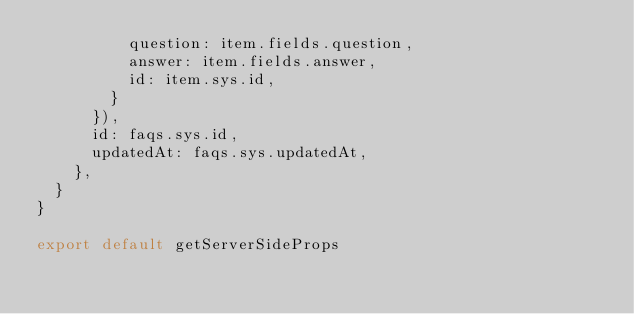<code> <loc_0><loc_0><loc_500><loc_500><_TypeScript_>          question: item.fields.question,
          answer: item.fields.answer,
          id: item.sys.id,
        }
      }),
      id: faqs.sys.id,
      updatedAt: faqs.sys.updatedAt,
    },
  }
}

export default getServerSideProps
</code> 